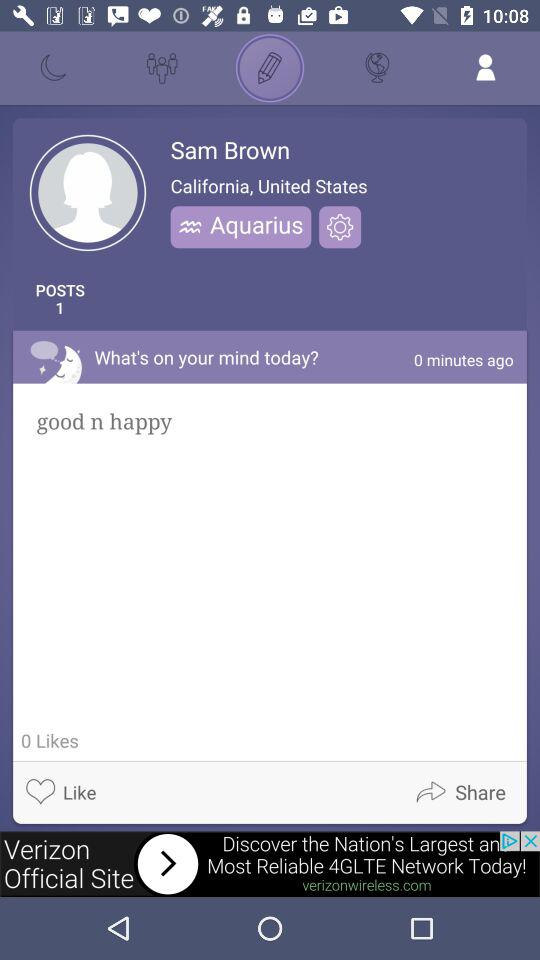What is the profile name? The profile name is Sam Brown. 